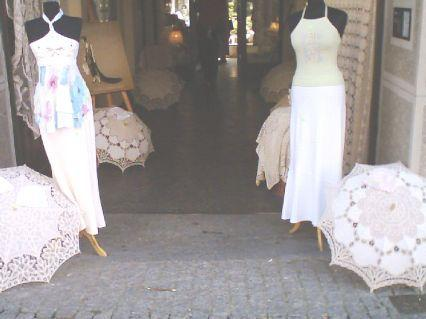How many dresses are sat around the entryway to the hall? Please explain your reasoning. two. There are two dresses. 